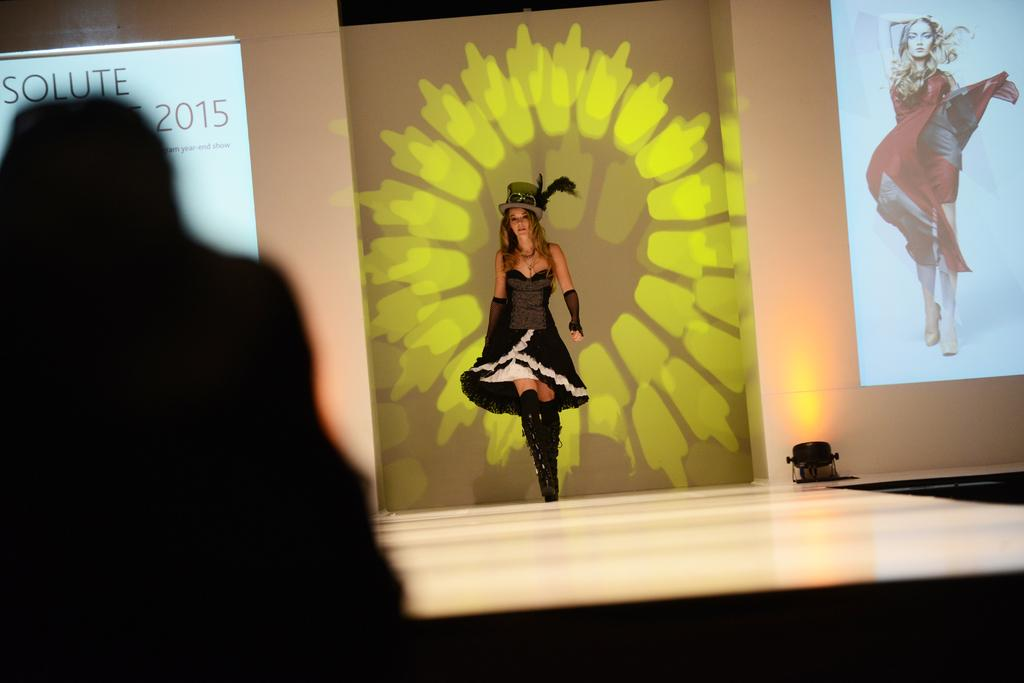Who is the main subject in the image? There is a lady in the image. the image. What is the lady doing in the image? The lady is walking on a ramp. What is the lady wearing in the image? The lady is wearing a hat. What can be seen in the background of the image? There are screens in the background of the image. What is displayed on the screens? The screens display text and an image of a lady. Can you describe the lighting in the image? There is a light visible in the image. Are there any fairies visible in the image? No, there are no fairies present in the image. What type of twig is the lady holding in the image? There is no twig visible in the image; the lady is not holding anything. 